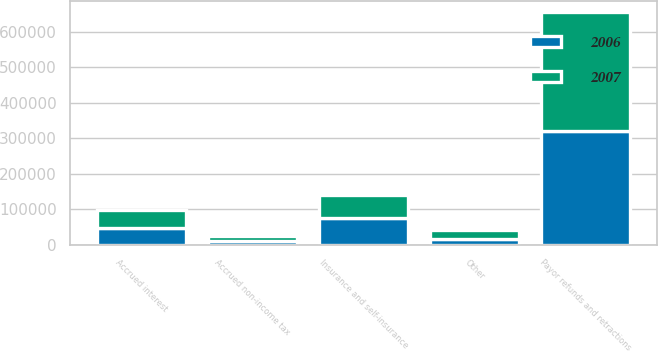<chart> <loc_0><loc_0><loc_500><loc_500><stacked_bar_chart><ecel><fcel>Payor refunds and retractions<fcel>Insurance and self-insurance<fcel>Accrued interest<fcel>Accrued non-income tax<fcel>Other<nl><fcel>2007<fcel>333089<fcel>66222<fcel>48506<fcel>12386<fcel>25948<nl><fcel>2006<fcel>322155<fcel>74607<fcel>48781<fcel>11610<fcel>16066<nl></chart> 